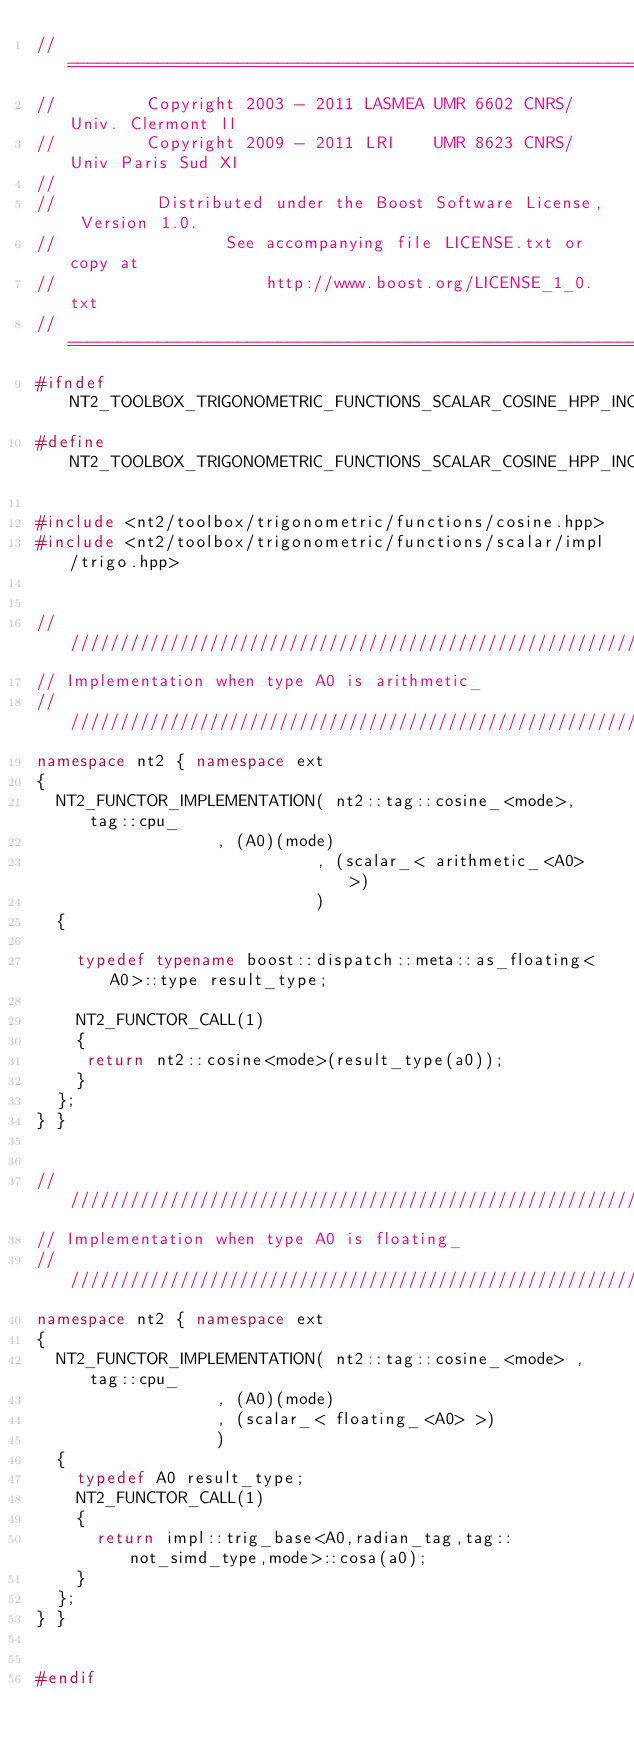Convert code to text. <code><loc_0><loc_0><loc_500><loc_500><_C++_>//==============================================================================
//         Copyright 2003 - 2011 LASMEA UMR 6602 CNRS/Univ. Clermont II
//         Copyright 2009 - 2011 LRI    UMR 8623 CNRS/Univ Paris Sud XI
//
//          Distributed under the Boost Software License, Version 1.0.
//                 See accompanying file LICENSE.txt or copy at
//                     http://www.boost.org/LICENSE_1_0.txt
//==============================================================================
#ifndef NT2_TOOLBOX_TRIGONOMETRIC_FUNCTIONS_SCALAR_COSINE_HPP_INCLUDED
#define NT2_TOOLBOX_TRIGONOMETRIC_FUNCTIONS_SCALAR_COSINE_HPP_INCLUDED

#include <nt2/toolbox/trigonometric/functions/cosine.hpp>
#include <nt2/toolbox/trigonometric/functions/scalar/impl/trigo.hpp>


/////////////////////////////////////////////////////////////////////////////
// Implementation when type A0 is arithmetic_
/////////////////////////////////////////////////////////////////////////////
namespace nt2 { namespace ext
{
  NT2_FUNCTOR_IMPLEMENTATION( nt2::tag::cosine_<mode>, tag::cpu_
			      , (A0)(mode)
                            , (scalar_< arithmetic_<A0> >)
                            )
  {

    typedef typename boost::dispatch::meta::as_floating<A0>::type result_type;

    NT2_FUNCTOR_CALL(1)
    {
     return nt2::cosine<mode>(result_type(a0));
    }
  };
} }


/////////////////////////////////////////////////////////////////////////////
// Implementation when type A0 is floating_
/////////////////////////////////////////////////////////////////////////////
namespace nt2 { namespace ext
{
  NT2_FUNCTOR_IMPLEMENTATION( nt2::tag::cosine_<mode> , tag::cpu_
			      , (A0)(mode)
			      , (scalar_< floating_<A0> >)
			      )
  {
    typedef A0 result_type;
    NT2_FUNCTOR_CALL(1)
    {
      return impl::trig_base<A0,radian_tag,tag::not_simd_type,mode>::cosa(a0);
    }
  };
} }


#endif
</code> 